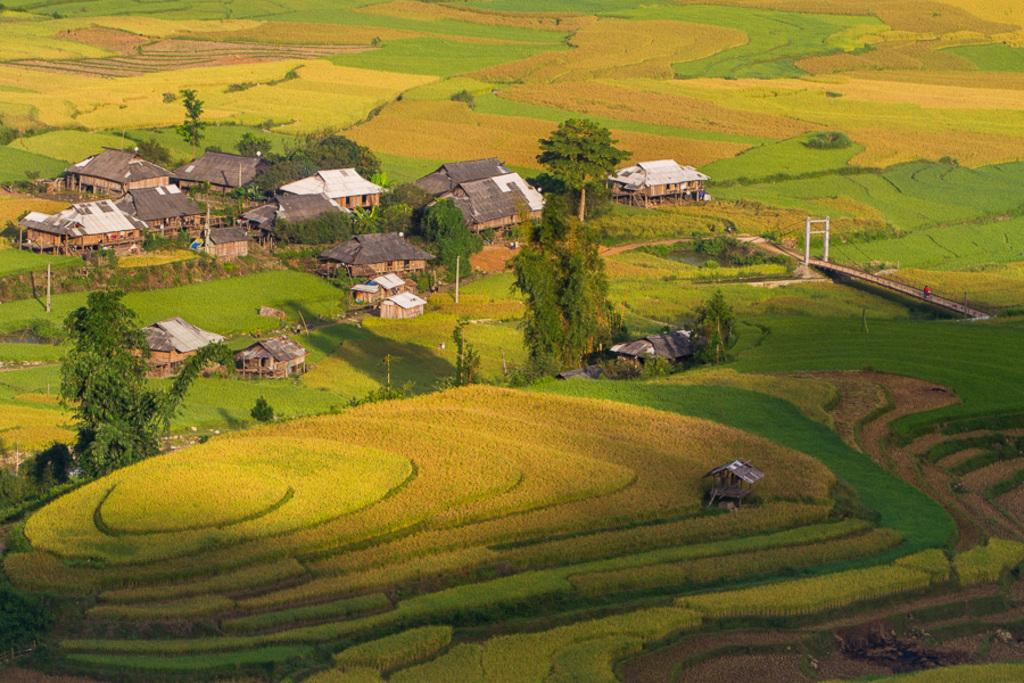What type of structures can be seen in the image? There are houses in the image. What type of natural elements are present in the image? There are trees, grass, and plants in the image. What type of man-made objects can be seen in the image? There are poles and a bridge in the image. Are there any living beings in the image? Yes, there is a person in the image. What type of cap is the fireman wearing in the image? There is no fireman or cap present in the image. Is the person in the image walking in space? There is no indication of space or a person walking in space in the image. 